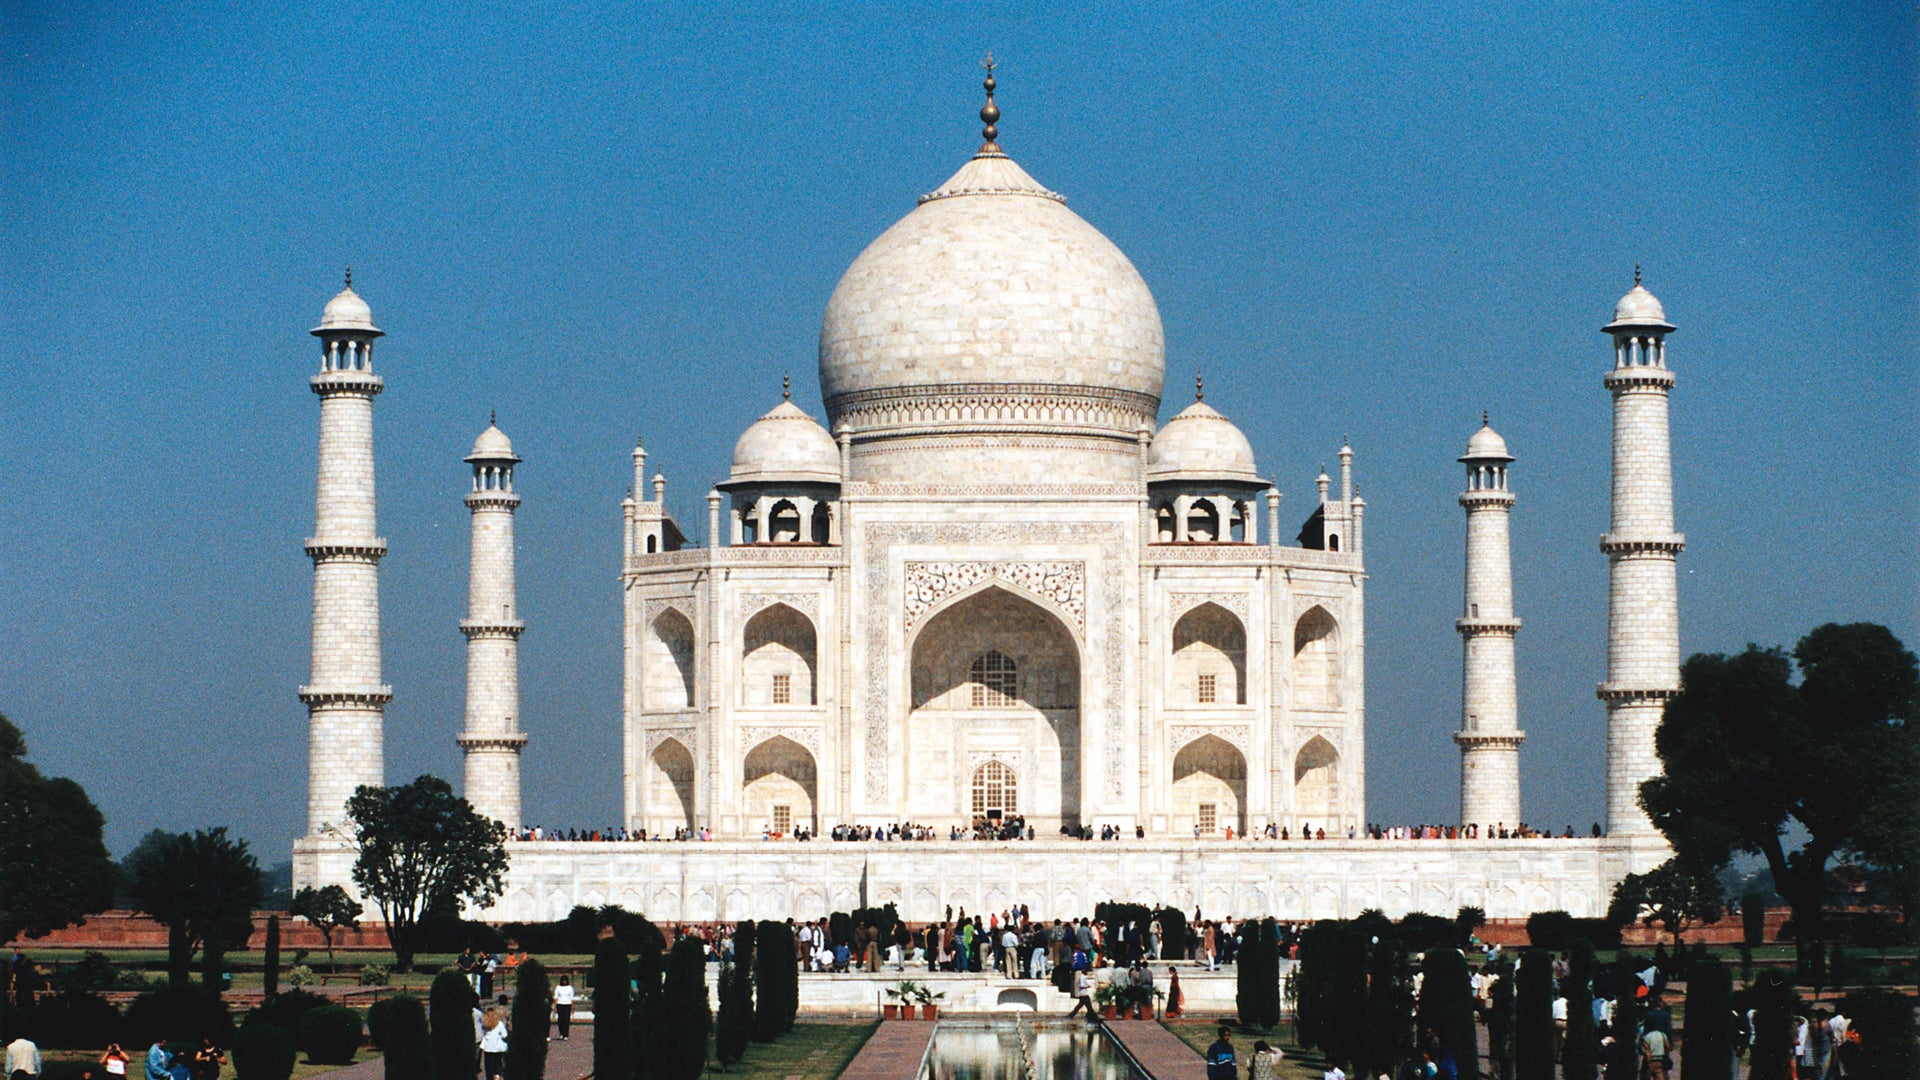Can you share some information about the gardens that surround the Taj Mahal? Certainly. The Taj Mahal is surrounded by Mughal gardens, known as 'charbagh' or 'four gardens', which symbolize the four flowing rivers of Jannah (Paradise) as described in Islamic scriptures. These gardens are divided into quadrants by waterways, reflecting the Persian influence on Mughal garden design. They were meticulously planned to emphasize the symmetry and harmonious aesthetic integral to the complex. These lush landscapes not only enhance the tranquility and beauty of the site but also serve as a contrast to the pristine white marble of the mausoleum. 